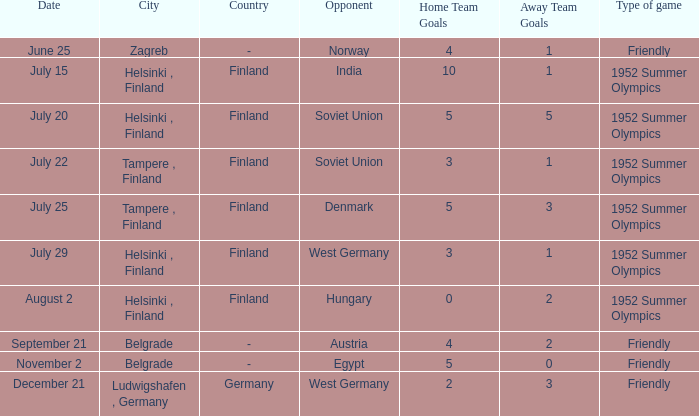Parse the full table. {'header': ['Date', 'City', 'Country', 'Opponent', 'Home Team Goals', 'Away Team Goals', 'Type of game'], 'rows': [['June 25', 'Zagreb', '-', 'Norway', '4', '1', 'Friendly'], ['July 15', 'Helsinki , Finland', 'Finland', 'India', '10', '1', '1952 Summer Olympics'], ['July 20', 'Helsinki , Finland', 'Finland', 'Soviet Union', '5', '5', '1952 Summer Olympics'], ['July 22', 'Tampere , Finland', 'Finland', 'Soviet Union', '3', '1', '1952 Summer Olympics'], ['July 25', 'Tampere , Finland', 'Finland', 'Denmark', '5', '3', '1952 Summer Olympics'], ['July 29', 'Helsinki , Finland', 'Finland', 'West Germany', '3', '1', '1952 Summer Olympics'], ['August 2', 'Helsinki , Finland', 'Finland', 'Hungary', '0', '2', '1952 Summer Olympics'], ['September 21', 'Belgrade', '-', 'Austria', '4', '2', 'Friendly'], ['November 2', 'Belgrade', '-', 'Egypt', '5', '0', 'Friendly'], ['December 21', 'Ludwigshafen , Germany', 'Germany', 'West Germany', '2', '3', 'Friendly']]} What Type of game has a Results¹ of 10:1? 1952 Summer Olympics. 